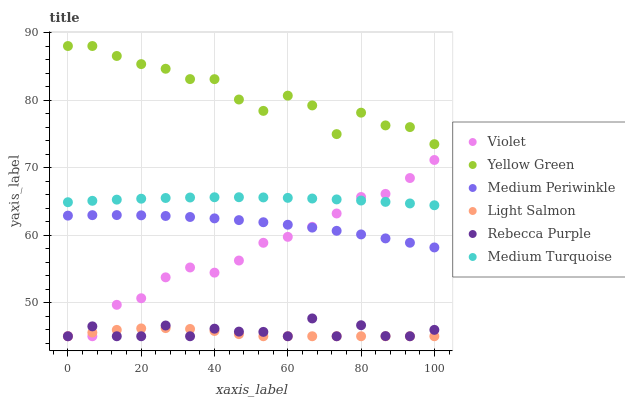Does Light Salmon have the minimum area under the curve?
Answer yes or no. Yes. Does Yellow Green have the maximum area under the curve?
Answer yes or no. Yes. Does Medium Periwinkle have the minimum area under the curve?
Answer yes or no. No. Does Medium Periwinkle have the maximum area under the curve?
Answer yes or no. No. Is Medium Turquoise the smoothest?
Answer yes or no. Yes. Is Yellow Green the roughest?
Answer yes or no. Yes. Is Medium Periwinkle the smoothest?
Answer yes or no. No. Is Medium Periwinkle the roughest?
Answer yes or no. No. Does Light Salmon have the lowest value?
Answer yes or no. Yes. Does Medium Periwinkle have the lowest value?
Answer yes or no. No. Does Yellow Green have the highest value?
Answer yes or no. Yes. Does Medium Periwinkle have the highest value?
Answer yes or no. No. Is Medium Turquoise less than Yellow Green?
Answer yes or no. Yes. Is Yellow Green greater than Light Salmon?
Answer yes or no. Yes. Does Medium Periwinkle intersect Violet?
Answer yes or no. Yes. Is Medium Periwinkle less than Violet?
Answer yes or no. No. Is Medium Periwinkle greater than Violet?
Answer yes or no. No. Does Medium Turquoise intersect Yellow Green?
Answer yes or no. No. 